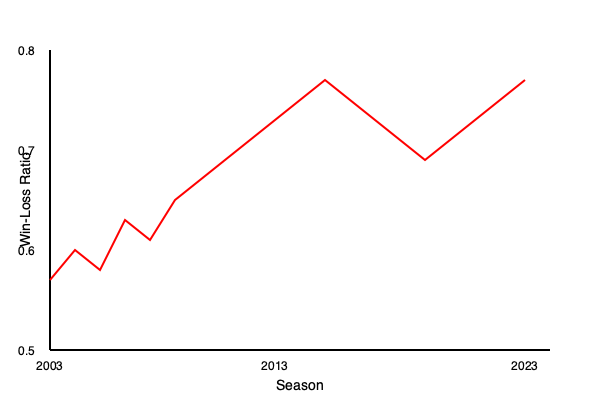Based on the line graph showing Ohio State's basketball win-loss record over the past 20 seasons, in which period did the team experience its most consistent improvement in performance? To answer this question, we need to analyze the trend of the line graph from left to right (2003 to 2023):

1. From 2003 to 2008 (first quarter of the graph), the line shows fluctuations with no consistent upward trend.

2. From 2008 to 2013 (second quarter), we see a steady upward trend, indicating consistent improvement in the win-loss ratio.

3. From 2013 to 2018 (third quarter), the line plateaus and then slightly declines, showing no improvement.

4. From 2018 to 2023 (last quarter), the line fluctuates again with no clear upward trend.

The most consistent improvement is observed in the period from 2008 to 2013, where the line shows a steady upward trajectory without significant dips or fluctuations.
Answer: 2008 to 2013 